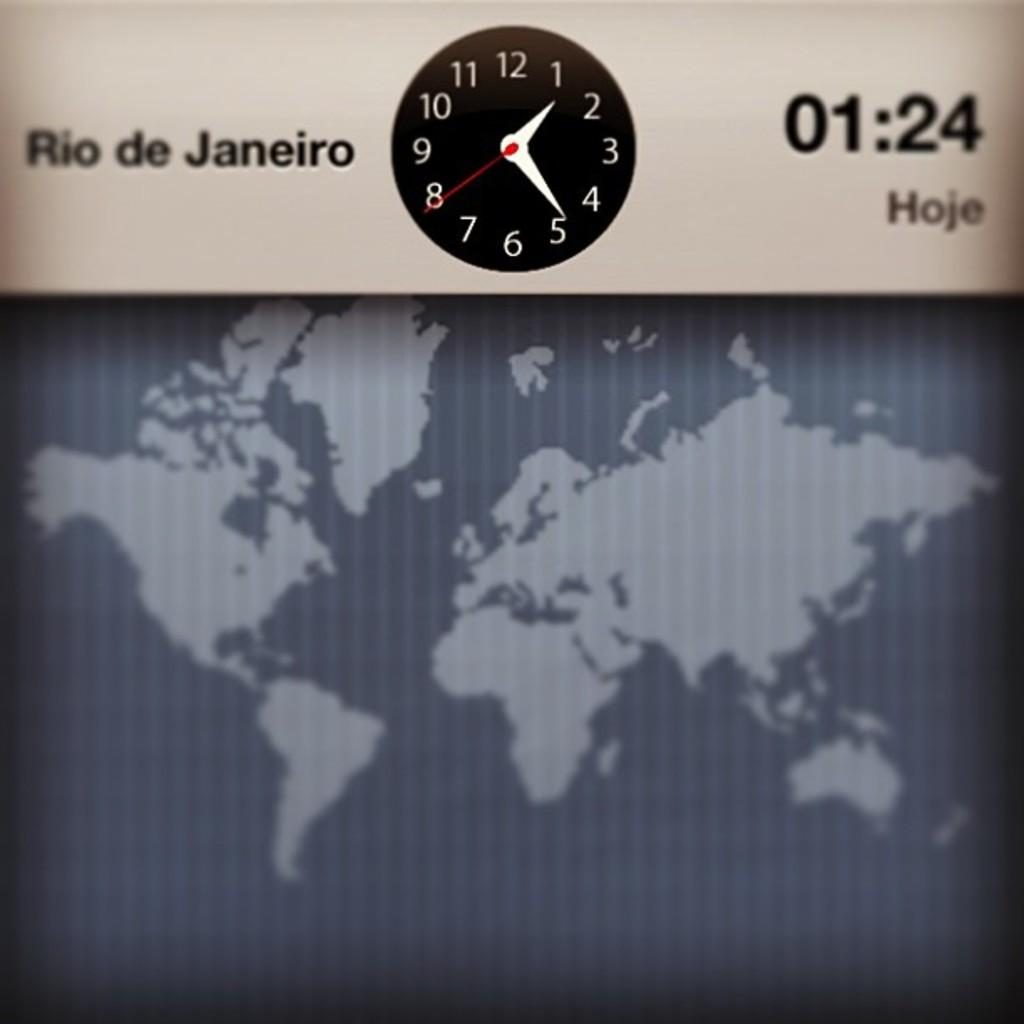<image>
Relay a brief, clear account of the picture shown. A clock displaying the time in Rio de Janeiro of 1:24 